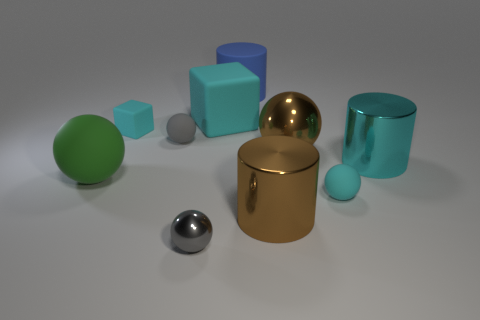Subtract all brown balls. How many balls are left? 4 Subtract all big brown spheres. How many spheres are left? 4 Subtract all purple balls. Subtract all yellow cylinders. How many balls are left? 5 Subtract all cylinders. How many objects are left? 7 Subtract all tiny gray balls. Subtract all large shiny spheres. How many objects are left? 7 Add 4 small gray metallic objects. How many small gray metallic objects are left? 5 Add 1 tiny rubber blocks. How many tiny rubber blocks exist? 2 Subtract 0 brown blocks. How many objects are left? 10 